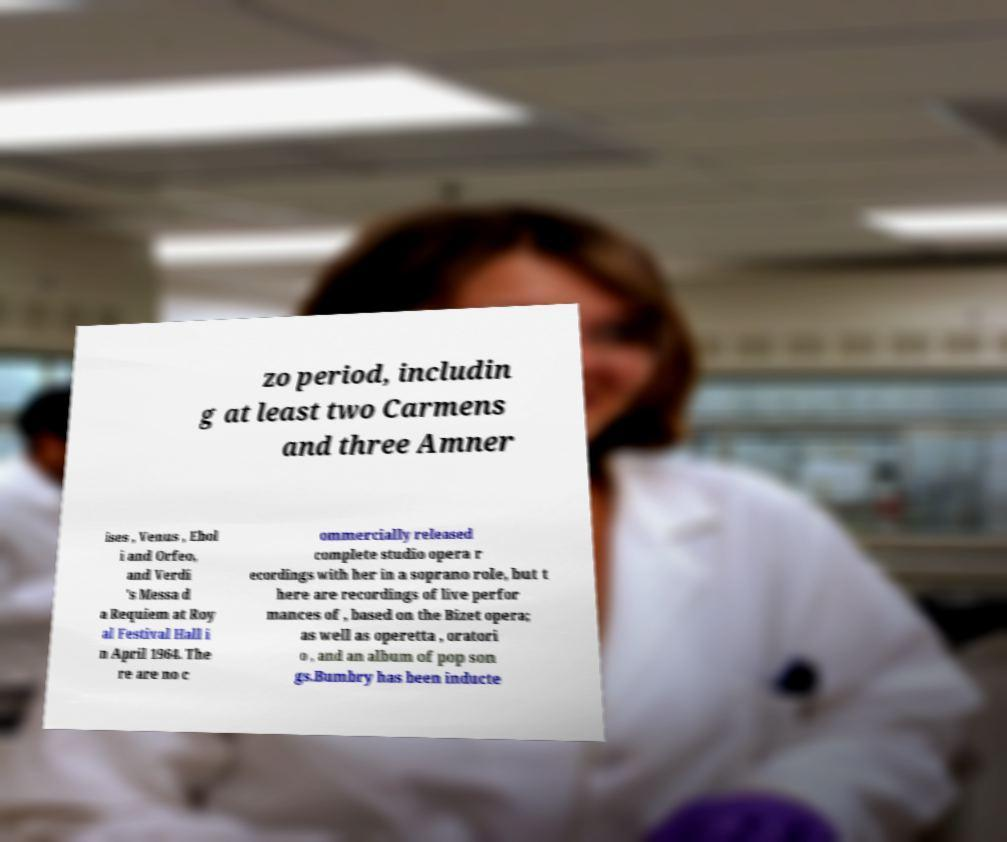I need the written content from this picture converted into text. Can you do that? zo period, includin g at least two Carmens and three Amner ises , Venus , Ebol i and Orfeo, and Verdi 's Messa d a Requiem at Roy al Festival Hall i n April 1964. The re are no c ommercially released complete studio opera r ecordings with her in a soprano role, but t here are recordings of live perfor mances of , based on the Bizet opera; as well as operetta , oratori o , and an album of pop son gs.Bumbry has been inducte 